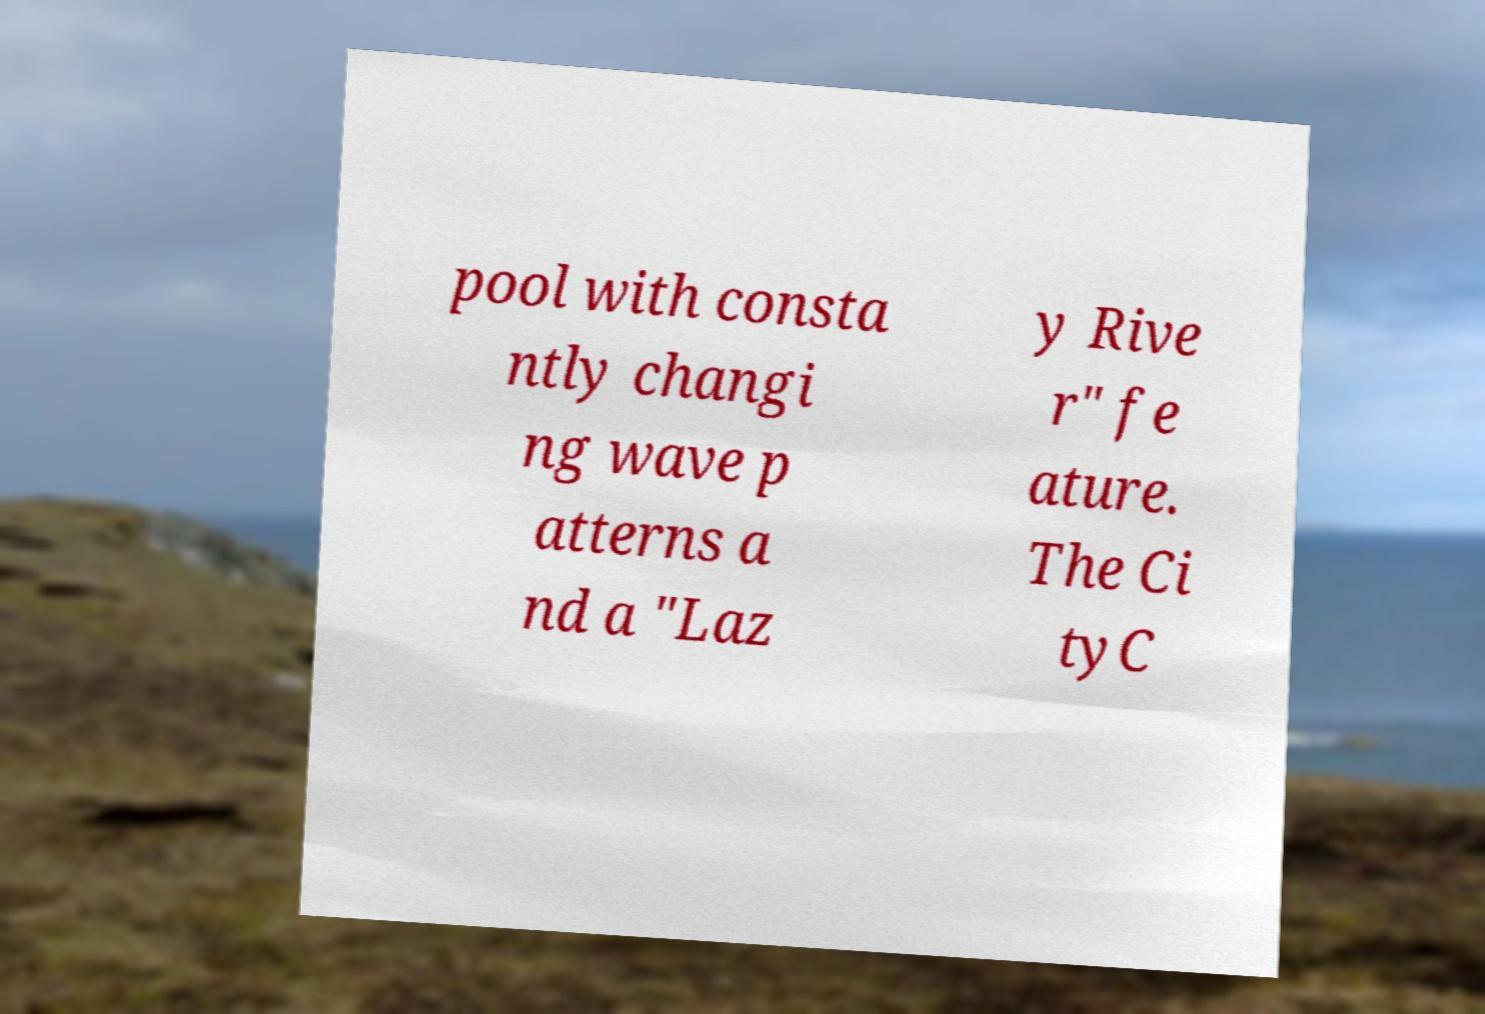There's text embedded in this image that I need extracted. Can you transcribe it verbatim? pool with consta ntly changi ng wave p atterns a nd a "Laz y Rive r" fe ature. The Ci tyC 